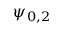<formula> <loc_0><loc_0><loc_500><loc_500>\psi _ { 0 , 2 }</formula> 